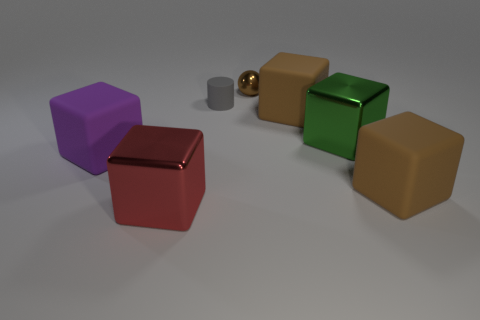Are the red thing and the small cylinder made of the same material?
Your answer should be compact. No. Does the small matte object have the same color as the ball?
Make the answer very short. No. How many other gray objects have the same shape as the small gray rubber object?
Keep it short and to the point. 0. The green thing that is the same material as the small brown ball is what size?
Make the answer very short. Large. Is the gray cylinder the same size as the brown shiny ball?
Make the answer very short. Yes. Is there a big red metal cube?
Ensure brevity in your answer.  Yes. There is a metallic block to the right of the brown block that is left of the brown block that is in front of the purple rubber thing; what is its size?
Offer a very short reply. Large. How many other balls are made of the same material as the small sphere?
Make the answer very short. 0. What number of red metallic cubes have the same size as the green shiny cube?
Provide a succinct answer. 1. What material is the big brown object behind the rubber cube left of the metallic thing that is in front of the large purple rubber block?
Offer a very short reply. Rubber. 